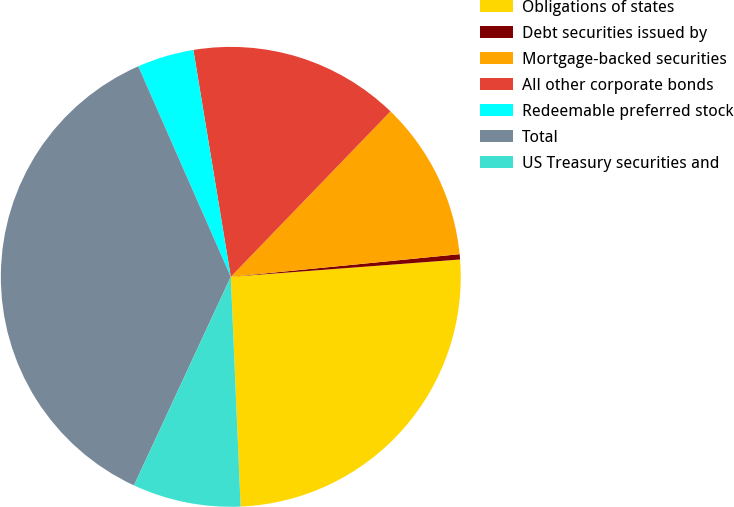Convert chart to OTSL. <chart><loc_0><loc_0><loc_500><loc_500><pie_chart><fcel>Obligations of states<fcel>Debt securities issued by<fcel>Mortgage-backed securities<fcel>All other corporate bonds<fcel>Redeemable preferred stock<fcel>Total<fcel>US Treasury securities and<nl><fcel>25.52%<fcel>0.37%<fcel>11.21%<fcel>14.82%<fcel>3.99%<fcel>36.49%<fcel>7.6%<nl></chart> 